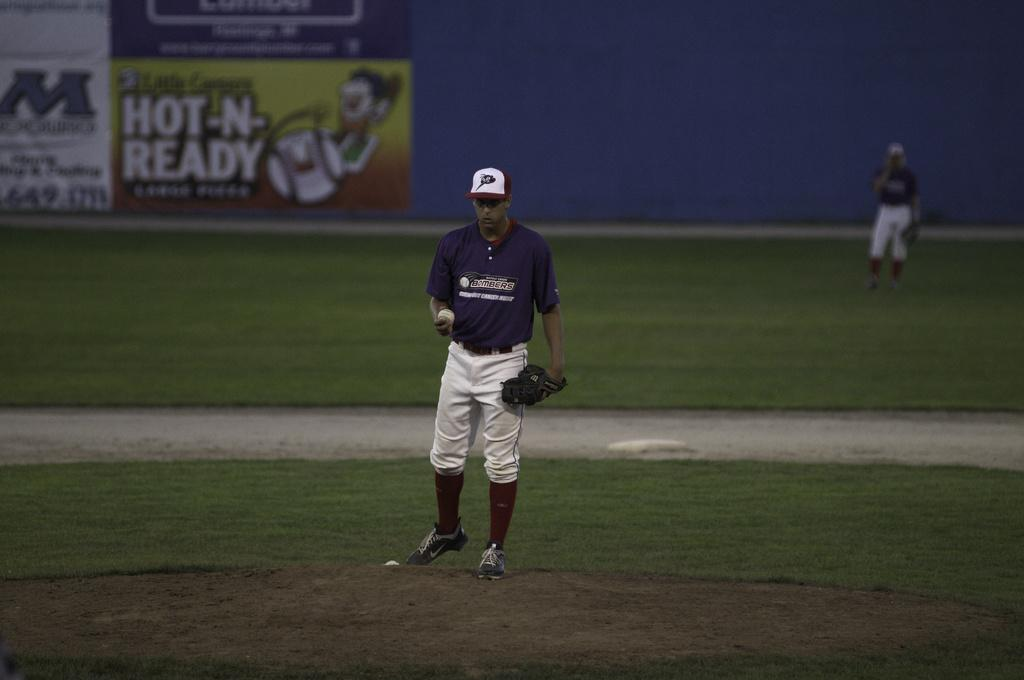<image>
Summarize the visual content of the image. a player that has the team name Bombers on the jersey 